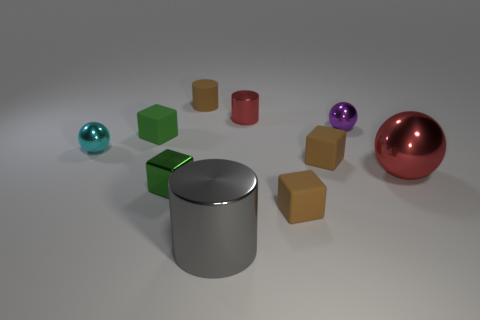Is there any other thing that has the same shape as the cyan thing?
Provide a succinct answer. Yes. There is a red object that is to the right of the tiny purple shiny ball; what is it made of?
Your answer should be compact. Metal. Is the material of the tiny cylinder that is behind the tiny red object the same as the gray cylinder?
Keep it short and to the point. No. What number of things are small cyan metal balls or tiny metallic things that are on the right side of the cyan ball?
Provide a succinct answer. 4. There is a cyan thing that is the same shape as the big red object; what size is it?
Your answer should be compact. Small. Is there anything else that has the same size as the purple shiny thing?
Your answer should be very brief. Yes. Are there any tiny red metallic cylinders behind the brown matte cylinder?
Offer a terse response. No. There is a sphere that is to the left of the purple sphere; is its color the same as the big metallic thing on the left side of the large red metal sphere?
Ensure brevity in your answer.  No. Are there any big gray objects of the same shape as the small cyan object?
Ensure brevity in your answer.  No. What number of other things are the same color as the matte cylinder?
Your answer should be compact. 2. 